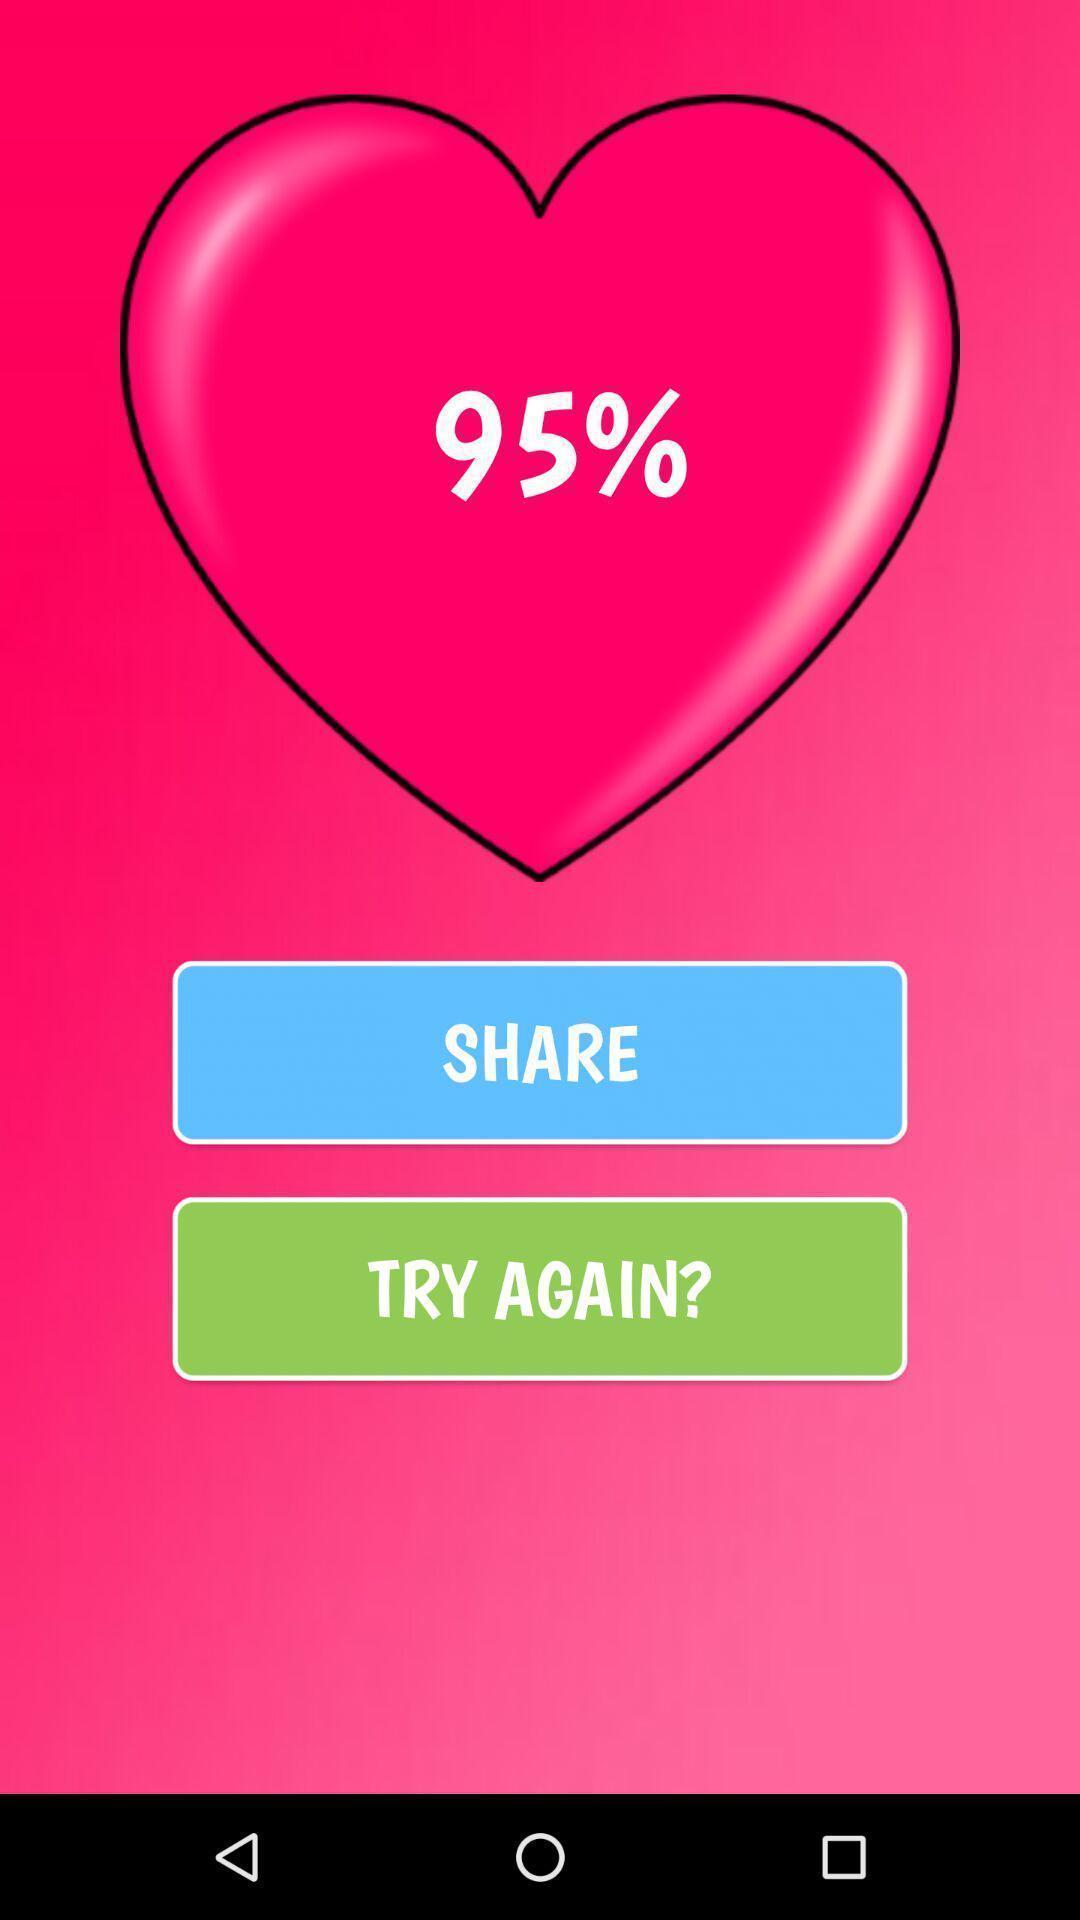Describe the key features of this screenshot. Screen shows multiple options. 